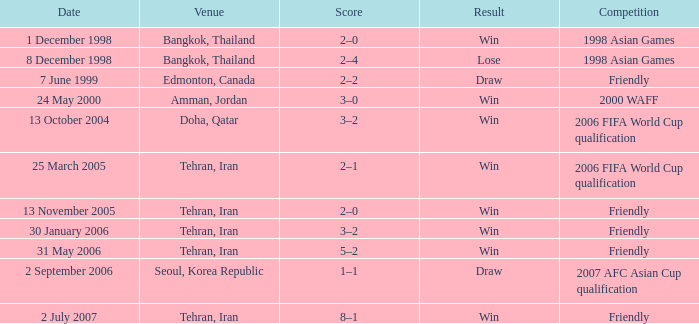Where was the friendly competition on 7 June 1999 played? Edmonton, Canada. 